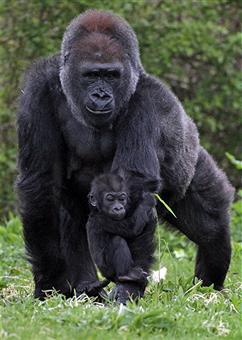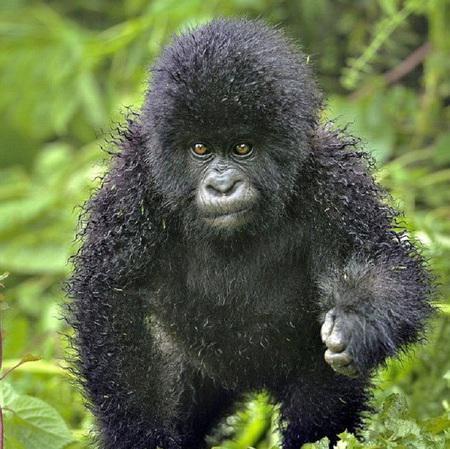The first image is the image on the left, the second image is the image on the right. Assess this claim about the two images: "There are parts of at least four gorillas visible.". Correct or not? Answer yes or no. No. The first image is the image on the left, the second image is the image on the right. Considering the images on both sides, is "An image shows a gorilla sitting and holding a baby animal to its chest." valid? Answer yes or no. No. 